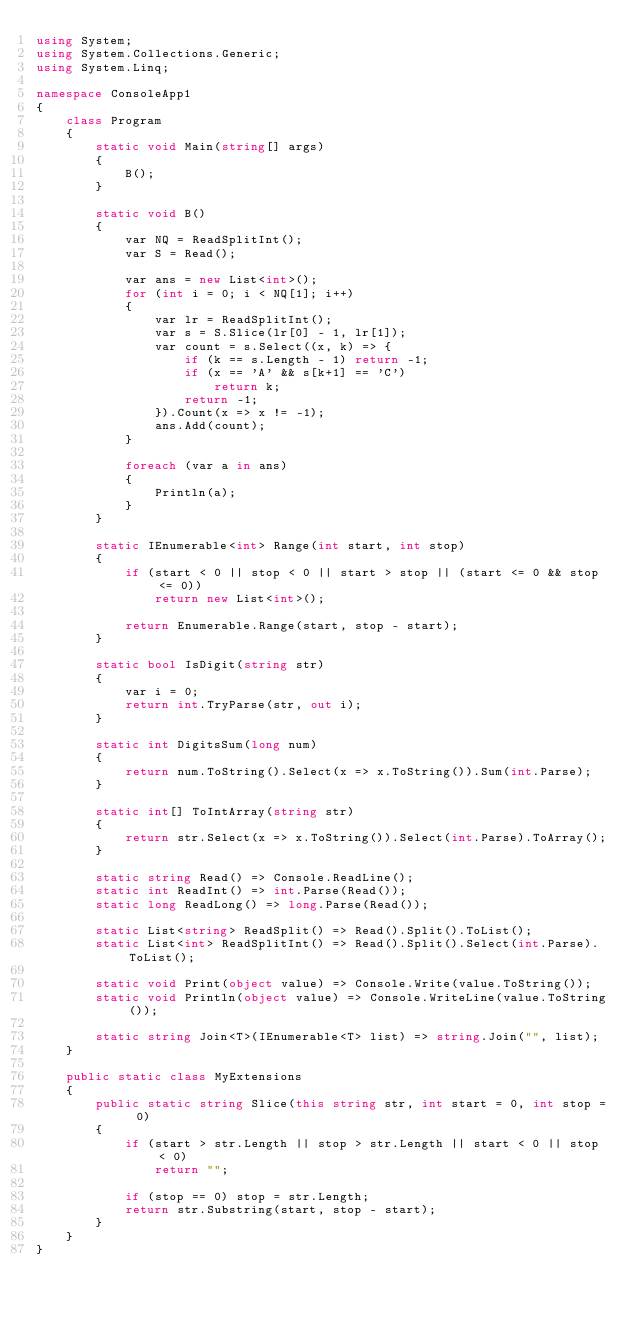Convert code to text. <code><loc_0><loc_0><loc_500><loc_500><_C#_>using System;
using System.Collections.Generic;
using System.Linq;

namespace ConsoleApp1
{
    class Program
    {
        static void Main(string[] args)
        {
            B();
        }

        static void B()
        {
            var NQ = ReadSplitInt();
            var S = Read();

            var ans = new List<int>();
            for (int i = 0; i < NQ[1]; i++)
            {
                var lr = ReadSplitInt();
                var s = S.Slice(lr[0] - 1, lr[1]);
                var count = s.Select((x, k) => {
                    if (k == s.Length - 1) return -1;
                    if (x == 'A' && s[k+1] == 'C')
                        return k;
                    return -1;
                }).Count(x => x != -1);
                ans.Add(count);
            }

            foreach (var a in ans)
            {
                Println(a);
            }
        }

        static IEnumerable<int> Range(int start, int stop)
        {
            if (start < 0 || stop < 0 || start > stop || (start <= 0 && stop <= 0))
                return new List<int>();

            return Enumerable.Range(start, stop - start);
        }

        static bool IsDigit(string str)
        {
            var i = 0;
            return int.TryParse(str, out i);
        }

        static int DigitsSum(long num)
        {
            return num.ToString().Select(x => x.ToString()).Sum(int.Parse);
        }

        static int[] ToIntArray(string str)
        {
            return str.Select(x => x.ToString()).Select(int.Parse).ToArray();
        }

        static string Read() => Console.ReadLine();
        static int ReadInt() => int.Parse(Read());
        static long ReadLong() => long.Parse(Read());

        static List<string> ReadSplit() => Read().Split().ToList();
        static List<int> ReadSplitInt() => Read().Split().Select(int.Parse).ToList();

        static void Print(object value) => Console.Write(value.ToString());
        static void Println(object value) => Console.WriteLine(value.ToString());

        static string Join<T>(IEnumerable<T> list) => string.Join("", list);
    }

    public static class MyExtensions
    {
        public static string Slice(this string str, int start = 0, int stop = 0)
        {
            if (start > str.Length || stop > str.Length || start < 0 || stop < 0)
                return "";

            if (stop == 0) stop = str.Length;
            return str.Substring(start, stop - start);
        }
    }
}</code> 